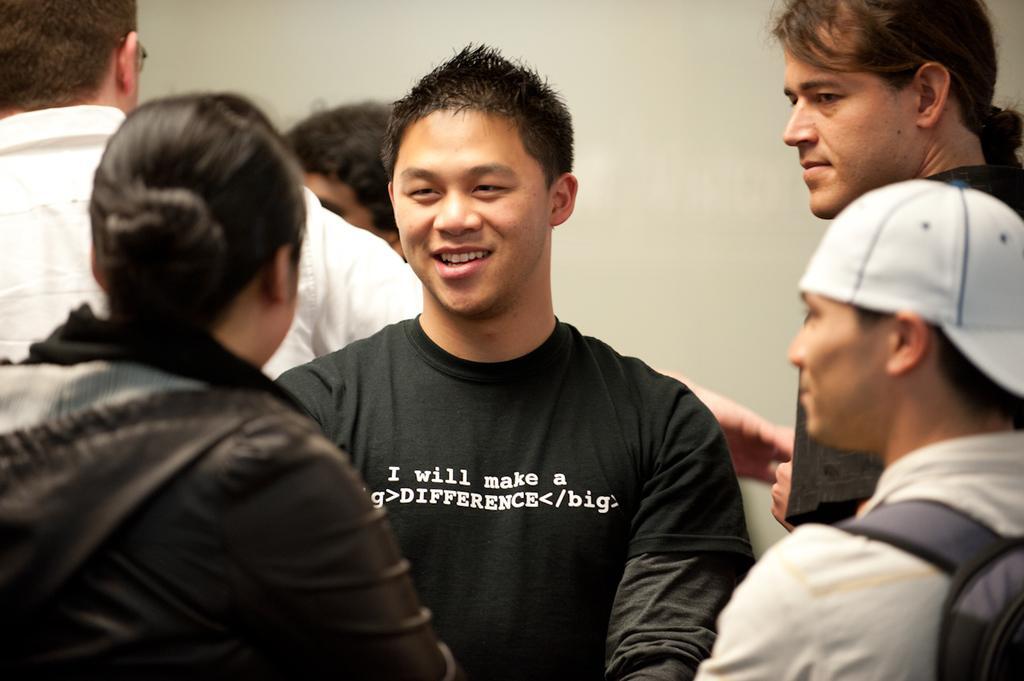Describe this image in one or two sentences. This is the man standing and smiling. I can see a group of people standing. In the background, that looks like a wall, which is white in color. 